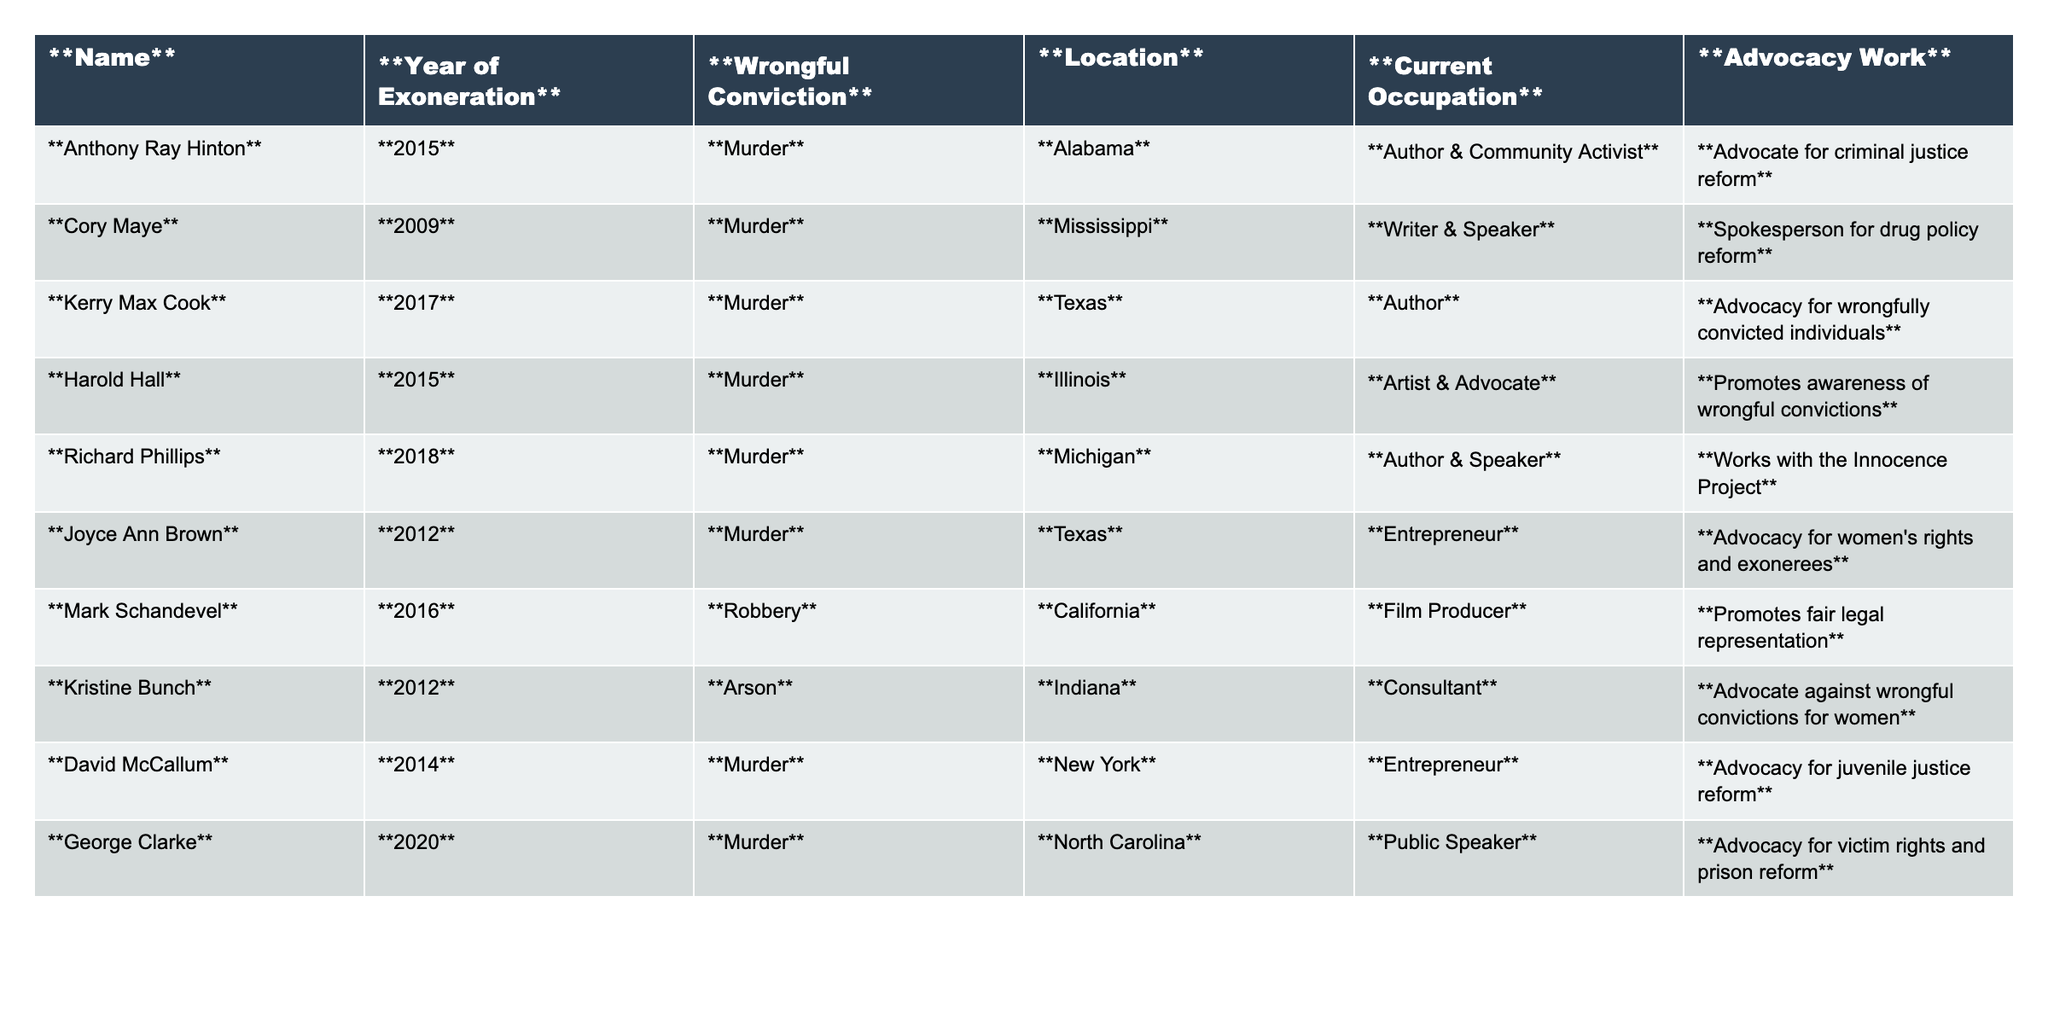What year was Anthony Ray Hinton exonerated? The table lists Anthony Ray Hinton under the "Year of Exoneration" column with the value 2015.
Answer: 2015 Which individual from Texas is an entrepreneur? The table shows Joyce Ann Brown as being from Texas and listed under "Current Occupation" as an Entrepreneur.
Answer: Joyce Ann Brown How many individuals are listed as authors? According to the table, there are four individuals listed under the "Current Occupation" as Author (Anthony Ray Hinton, Kerry Max Cook, Richard Phillips, and Harold Hall) summing up the count gives us 4.
Answer: 4 Is George Clarke involved in advocacy for women's rights? The table does not indicate that George Clarke is involved in advocacy for women's rights; instead, it states he focuses on victim rights and prison reform.
Answer: No From which state is the individual advocating for juvenile justice reform? David McCallum is listed in the table under "Location" as being from New York and his advocacy work is related to juvenile justice reform.
Answer: New York Which wrongful conviction type has the most individuals exonerated? The table shows that the murder category has six individuals (Anthony Ray Hinton, Cory Maye, Kerry Max Cook, Harold Hall, Richard Phillips, and George Clarke) while robbery and arson each have one individual. Therefore, murder has the most.
Answer: Murder What is the primary advocacy work of Mark Schandevel? The table states that Mark Schandevel promotes fair legal representation as his advocacy work, which can be directly observed in the "Advocacy Work" column.
Answer: Promotes fair legal representation List the occupations of individuals exonerated in 2012. Referring to the table, individuals exonerated in 2012 include Kristine Bunch (Consultant), Joyce Ann Brown (Entrepreneur), and since there are three listed, we can simply state their occupations.
Answer: Consultant, Entrepreneur Which individual works with the Innocence Project? Richard Phillips is noted in the table under the "Advocacy Work" column, indicating his collaboration with the Innocence Project.
Answer: Richard Phillips Are there more individuals exonerated in odd or even years? Exonerated individuals in odd years: 2009 (Cory Maye), 2011 (none), 2013 (none), 2015 (Anthony Ray Hinton, Harold Hall), 2017 (Kerry Max Cook), 2019 (none), 2021 (none), 2023 (none) = 3. Exonerated individuals in even years: 2010 (none), 2012 (Kristine Bunch, Joyce Ann Brown), 2014 (David McCallum), 2016 (Mark Schandevel), 2018 (Richard Phillips), 2020 (George Clarke) = 5. Therefore, there are more in even years.
Answer: Even years Which individual has the earliest year of exoneration listed? Looking through the "Year of Exoneration" column, Cory Maye has the earliest year, which is 2009.
Answer: Cory Maye 